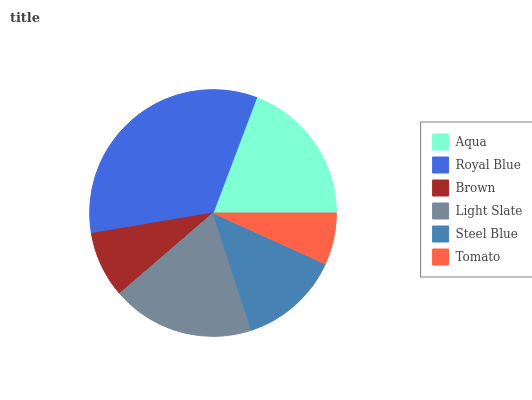Is Tomato the minimum?
Answer yes or no. Yes. Is Royal Blue the maximum?
Answer yes or no. Yes. Is Brown the minimum?
Answer yes or no. No. Is Brown the maximum?
Answer yes or no. No. Is Royal Blue greater than Brown?
Answer yes or no. Yes. Is Brown less than Royal Blue?
Answer yes or no. Yes. Is Brown greater than Royal Blue?
Answer yes or no. No. Is Royal Blue less than Brown?
Answer yes or no. No. Is Light Slate the high median?
Answer yes or no. Yes. Is Steel Blue the low median?
Answer yes or no. Yes. Is Steel Blue the high median?
Answer yes or no. No. Is Royal Blue the low median?
Answer yes or no. No. 